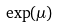<formula> <loc_0><loc_0><loc_500><loc_500>\exp ( \mu )</formula> 